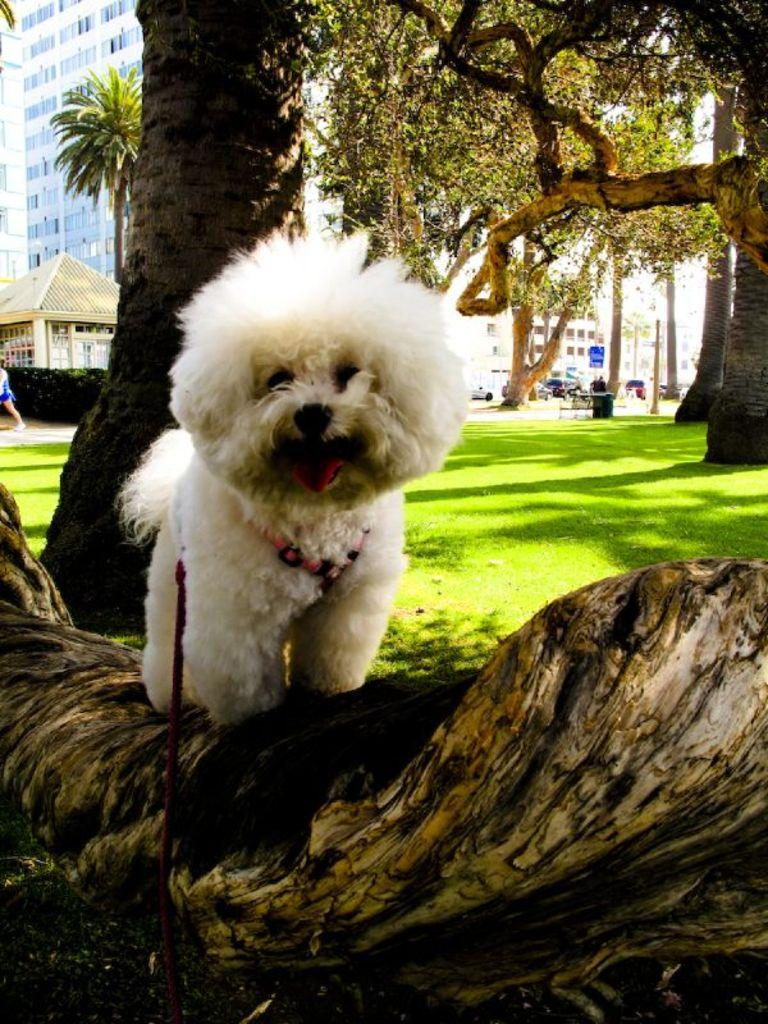What animal can be seen in the image? There is a dog in the image. How is the dog being controlled or restrained in the image? The dog is on a leash. Where is the dog located in the image? The dog is on a branch of a tree. What can be seen in the distance in the image? There are buildings and trees in the background of the image. What type of corn is growing on the dog's leash in the image? There is no corn present in the image, and the dog's leash is not associated with any plants or crops. 